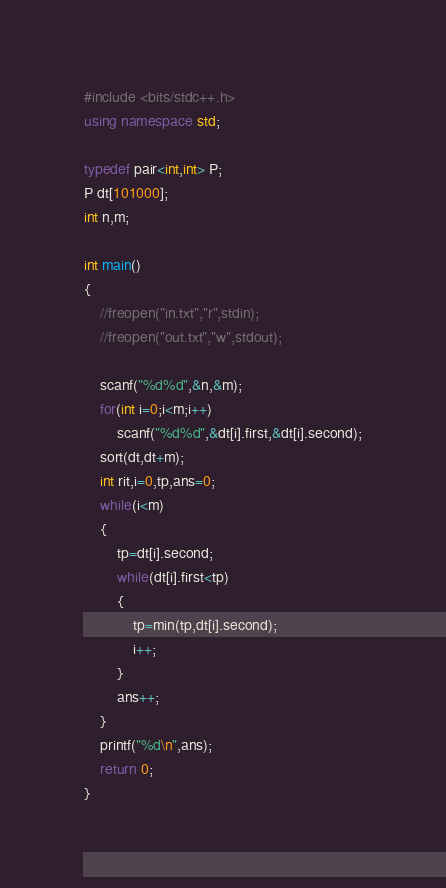<code> <loc_0><loc_0><loc_500><loc_500><_C++_>#include <bits/stdc++.h>
using namespace std;

typedef pair<int,int> P;
P dt[101000];
int n,m;

int main()
{
    //freopen("in.txt","r",stdin);
    //freopen("out.txt","w",stdout);

    scanf("%d%d",&n,&m);
    for(int i=0;i<m;i++)
        scanf("%d%d",&dt[i].first,&dt[i].second);
    sort(dt,dt+m);
    int rit,i=0,tp,ans=0;
    while(i<m)
    {
        tp=dt[i].second;
        while(dt[i].first<tp)
        {
            tp=min(tp,dt[i].second);
            i++;
        }
        ans++;
    }
    printf("%d\n",ans);
    return 0;
}
</code> 